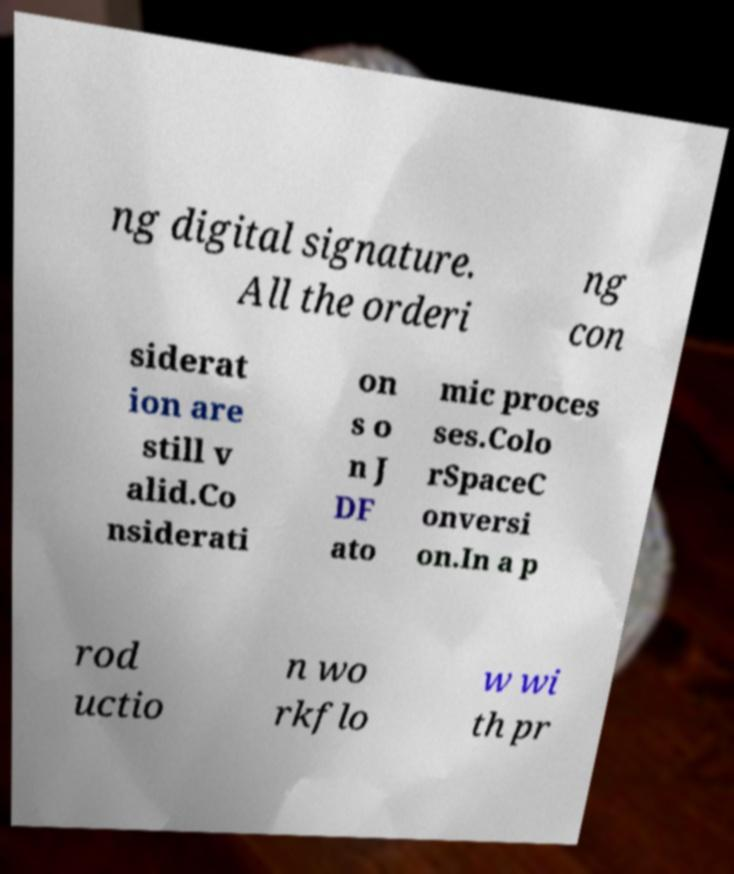There's text embedded in this image that I need extracted. Can you transcribe it verbatim? ng digital signature. All the orderi ng con siderat ion are still v alid.Co nsiderati on s o n J DF ato mic proces ses.Colo rSpaceC onversi on.In a p rod uctio n wo rkflo w wi th pr 